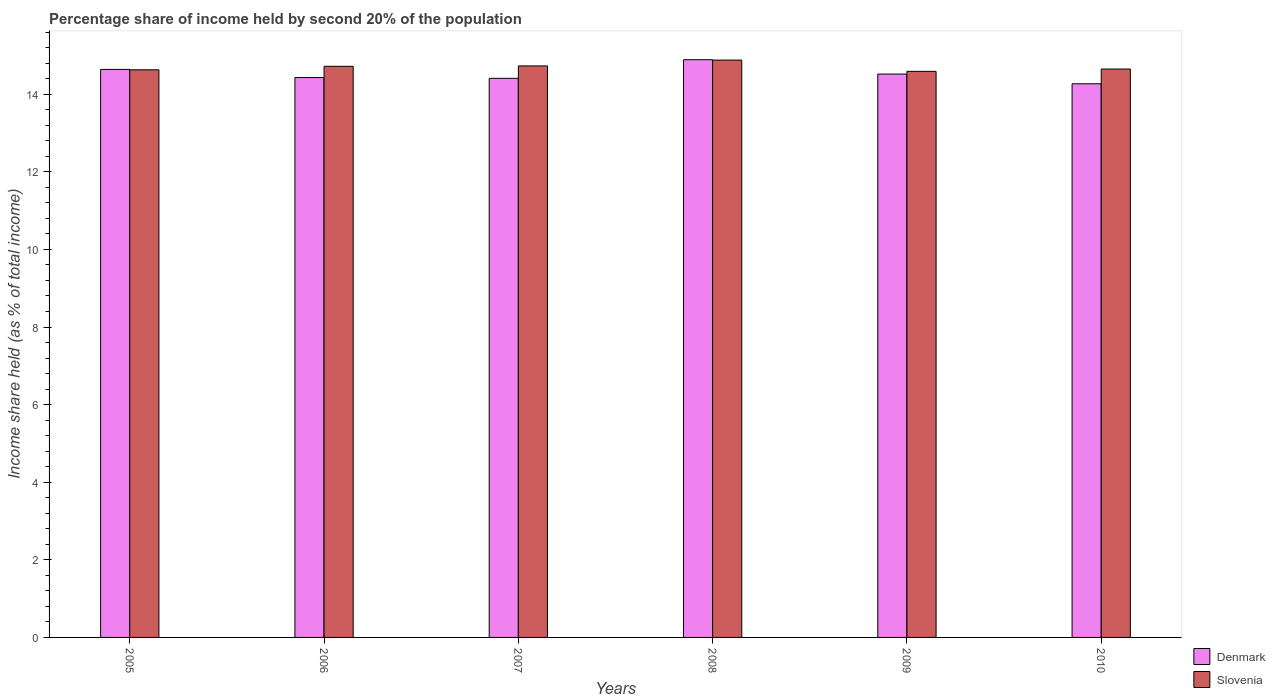How many different coloured bars are there?
Your answer should be compact. 2. How many groups of bars are there?
Provide a succinct answer. 6. How many bars are there on the 1st tick from the left?
Make the answer very short. 2. In how many cases, is the number of bars for a given year not equal to the number of legend labels?
Your response must be concise. 0. What is the share of income held by second 20% of the population in Slovenia in 2008?
Provide a succinct answer. 14.88. Across all years, what is the maximum share of income held by second 20% of the population in Denmark?
Your answer should be compact. 14.89. Across all years, what is the minimum share of income held by second 20% of the population in Slovenia?
Your answer should be compact. 14.59. In which year was the share of income held by second 20% of the population in Slovenia minimum?
Offer a terse response. 2009. What is the total share of income held by second 20% of the population in Slovenia in the graph?
Offer a very short reply. 88.2. What is the difference between the share of income held by second 20% of the population in Denmark in 2006 and that in 2009?
Keep it short and to the point. -0.09. What is the difference between the share of income held by second 20% of the population in Denmark in 2008 and the share of income held by second 20% of the population in Slovenia in 2006?
Make the answer very short. 0.17. What is the average share of income held by second 20% of the population in Denmark per year?
Your answer should be very brief. 14.53. In the year 2005, what is the difference between the share of income held by second 20% of the population in Slovenia and share of income held by second 20% of the population in Denmark?
Make the answer very short. -0.01. In how many years, is the share of income held by second 20% of the population in Slovenia greater than 10.8 %?
Give a very brief answer. 6. What is the ratio of the share of income held by second 20% of the population in Denmark in 2005 to that in 2007?
Your answer should be very brief. 1.02. Is the share of income held by second 20% of the population in Slovenia in 2005 less than that in 2008?
Your answer should be compact. Yes. Is the difference between the share of income held by second 20% of the population in Slovenia in 2006 and 2007 greater than the difference between the share of income held by second 20% of the population in Denmark in 2006 and 2007?
Offer a very short reply. No. What is the difference between the highest and the second highest share of income held by second 20% of the population in Slovenia?
Keep it short and to the point. 0.15. What is the difference between the highest and the lowest share of income held by second 20% of the population in Slovenia?
Your answer should be compact. 0.29. What does the 1st bar from the right in 2005 represents?
Your response must be concise. Slovenia. How many bars are there?
Offer a very short reply. 12. Are all the bars in the graph horizontal?
Give a very brief answer. No. Are the values on the major ticks of Y-axis written in scientific E-notation?
Make the answer very short. No. Does the graph contain any zero values?
Provide a short and direct response. No. Does the graph contain grids?
Give a very brief answer. No. How are the legend labels stacked?
Offer a terse response. Vertical. What is the title of the graph?
Give a very brief answer. Percentage share of income held by second 20% of the population. What is the label or title of the X-axis?
Offer a terse response. Years. What is the label or title of the Y-axis?
Provide a short and direct response. Income share held (as % of total income). What is the Income share held (as % of total income) in Denmark in 2005?
Offer a terse response. 14.64. What is the Income share held (as % of total income) of Slovenia in 2005?
Your answer should be compact. 14.63. What is the Income share held (as % of total income) in Denmark in 2006?
Your response must be concise. 14.43. What is the Income share held (as % of total income) in Slovenia in 2006?
Your answer should be very brief. 14.72. What is the Income share held (as % of total income) in Denmark in 2007?
Your answer should be very brief. 14.41. What is the Income share held (as % of total income) in Slovenia in 2007?
Offer a terse response. 14.73. What is the Income share held (as % of total income) in Denmark in 2008?
Your answer should be very brief. 14.89. What is the Income share held (as % of total income) of Slovenia in 2008?
Make the answer very short. 14.88. What is the Income share held (as % of total income) in Denmark in 2009?
Give a very brief answer. 14.52. What is the Income share held (as % of total income) of Slovenia in 2009?
Your answer should be very brief. 14.59. What is the Income share held (as % of total income) in Denmark in 2010?
Make the answer very short. 14.27. What is the Income share held (as % of total income) in Slovenia in 2010?
Provide a succinct answer. 14.65. Across all years, what is the maximum Income share held (as % of total income) of Denmark?
Keep it short and to the point. 14.89. Across all years, what is the maximum Income share held (as % of total income) of Slovenia?
Make the answer very short. 14.88. Across all years, what is the minimum Income share held (as % of total income) of Denmark?
Offer a very short reply. 14.27. Across all years, what is the minimum Income share held (as % of total income) of Slovenia?
Make the answer very short. 14.59. What is the total Income share held (as % of total income) of Denmark in the graph?
Your response must be concise. 87.16. What is the total Income share held (as % of total income) in Slovenia in the graph?
Your response must be concise. 88.2. What is the difference between the Income share held (as % of total income) in Denmark in 2005 and that in 2006?
Make the answer very short. 0.21. What is the difference between the Income share held (as % of total income) in Slovenia in 2005 and that in 2006?
Offer a very short reply. -0.09. What is the difference between the Income share held (as % of total income) of Denmark in 2005 and that in 2007?
Your response must be concise. 0.23. What is the difference between the Income share held (as % of total income) in Slovenia in 2005 and that in 2007?
Your response must be concise. -0.1. What is the difference between the Income share held (as % of total income) in Slovenia in 2005 and that in 2008?
Offer a very short reply. -0.25. What is the difference between the Income share held (as % of total income) of Denmark in 2005 and that in 2009?
Ensure brevity in your answer.  0.12. What is the difference between the Income share held (as % of total income) of Slovenia in 2005 and that in 2009?
Give a very brief answer. 0.04. What is the difference between the Income share held (as % of total income) in Denmark in 2005 and that in 2010?
Ensure brevity in your answer.  0.37. What is the difference between the Income share held (as % of total income) of Slovenia in 2005 and that in 2010?
Your answer should be compact. -0.02. What is the difference between the Income share held (as % of total income) in Slovenia in 2006 and that in 2007?
Your answer should be compact. -0.01. What is the difference between the Income share held (as % of total income) of Denmark in 2006 and that in 2008?
Ensure brevity in your answer.  -0.46. What is the difference between the Income share held (as % of total income) of Slovenia in 2006 and that in 2008?
Offer a terse response. -0.16. What is the difference between the Income share held (as % of total income) of Denmark in 2006 and that in 2009?
Offer a very short reply. -0.09. What is the difference between the Income share held (as % of total income) of Slovenia in 2006 and that in 2009?
Ensure brevity in your answer.  0.13. What is the difference between the Income share held (as % of total income) in Denmark in 2006 and that in 2010?
Your answer should be compact. 0.16. What is the difference between the Income share held (as % of total income) in Slovenia in 2006 and that in 2010?
Your answer should be very brief. 0.07. What is the difference between the Income share held (as % of total income) of Denmark in 2007 and that in 2008?
Ensure brevity in your answer.  -0.48. What is the difference between the Income share held (as % of total income) of Denmark in 2007 and that in 2009?
Ensure brevity in your answer.  -0.11. What is the difference between the Income share held (as % of total income) of Slovenia in 2007 and that in 2009?
Provide a succinct answer. 0.14. What is the difference between the Income share held (as % of total income) in Denmark in 2007 and that in 2010?
Keep it short and to the point. 0.14. What is the difference between the Income share held (as % of total income) in Slovenia in 2007 and that in 2010?
Provide a succinct answer. 0.08. What is the difference between the Income share held (as % of total income) in Denmark in 2008 and that in 2009?
Give a very brief answer. 0.37. What is the difference between the Income share held (as % of total income) of Slovenia in 2008 and that in 2009?
Offer a very short reply. 0.29. What is the difference between the Income share held (as % of total income) of Denmark in 2008 and that in 2010?
Offer a terse response. 0.62. What is the difference between the Income share held (as % of total income) of Slovenia in 2008 and that in 2010?
Provide a short and direct response. 0.23. What is the difference between the Income share held (as % of total income) of Denmark in 2009 and that in 2010?
Provide a succinct answer. 0.25. What is the difference between the Income share held (as % of total income) of Slovenia in 2009 and that in 2010?
Provide a short and direct response. -0.06. What is the difference between the Income share held (as % of total income) of Denmark in 2005 and the Income share held (as % of total income) of Slovenia in 2006?
Your answer should be very brief. -0.08. What is the difference between the Income share held (as % of total income) in Denmark in 2005 and the Income share held (as % of total income) in Slovenia in 2007?
Your response must be concise. -0.09. What is the difference between the Income share held (as % of total income) in Denmark in 2005 and the Income share held (as % of total income) in Slovenia in 2008?
Your response must be concise. -0.24. What is the difference between the Income share held (as % of total income) in Denmark in 2005 and the Income share held (as % of total income) in Slovenia in 2009?
Give a very brief answer. 0.05. What is the difference between the Income share held (as % of total income) of Denmark in 2005 and the Income share held (as % of total income) of Slovenia in 2010?
Your answer should be very brief. -0.01. What is the difference between the Income share held (as % of total income) of Denmark in 2006 and the Income share held (as % of total income) of Slovenia in 2007?
Your answer should be very brief. -0.3. What is the difference between the Income share held (as % of total income) in Denmark in 2006 and the Income share held (as % of total income) in Slovenia in 2008?
Your answer should be compact. -0.45. What is the difference between the Income share held (as % of total income) in Denmark in 2006 and the Income share held (as % of total income) in Slovenia in 2009?
Your answer should be very brief. -0.16. What is the difference between the Income share held (as % of total income) of Denmark in 2006 and the Income share held (as % of total income) of Slovenia in 2010?
Offer a very short reply. -0.22. What is the difference between the Income share held (as % of total income) of Denmark in 2007 and the Income share held (as % of total income) of Slovenia in 2008?
Provide a short and direct response. -0.47. What is the difference between the Income share held (as % of total income) in Denmark in 2007 and the Income share held (as % of total income) in Slovenia in 2009?
Provide a succinct answer. -0.18. What is the difference between the Income share held (as % of total income) of Denmark in 2007 and the Income share held (as % of total income) of Slovenia in 2010?
Ensure brevity in your answer.  -0.24. What is the difference between the Income share held (as % of total income) in Denmark in 2008 and the Income share held (as % of total income) in Slovenia in 2010?
Give a very brief answer. 0.24. What is the difference between the Income share held (as % of total income) in Denmark in 2009 and the Income share held (as % of total income) in Slovenia in 2010?
Keep it short and to the point. -0.13. What is the average Income share held (as % of total income) in Denmark per year?
Provide a short and direct response. 14.53. What is the average Income share held (as % of total income) in Slovenia per year?
Keep it short and to the point. 14.7. In the year 2005, what is the difference between the Income share held (as % of total income) in Denmark and Income share held (as % of total income) in Slovenia?
Your response must be concise. 0.01. In the year 2006, what is the difference between the Income share held (as % of total income) of Denmark and Income share held (as % of total income) of Slovenia?
Your answer should be very brief. -0.29. In the year 2007, what is the difference between the Income share held (as % of total income) of Denmark and Income share held (as % of total income) of Slovenia?
Your answer should be very brief. -0.32. In the year 2008, what is the difference between the Income share held (as % of total income) in Denmark and Income share held (as % of total income) in Slovenia?
Give a very brief answer. 0.01. In the year 2009, what is the difference between the Income share held (as % of total income) of Denmark and Income share held (as % of total income) of Slovenia?
Give a very brief answer. -0.07. In the year 2010, what is the difference between the Income share held (as % of total income) of Denmark and Income share held (as % of total income) of Slovenia?
Offer a terse response. -0.38. What is the ratio of the Income share held (as % of total income) in Denmark in 2005 to that in 2006?
Your answer should be compact. 1.01. What is the ratio of the Income share held (as % of total income) in Denmark in 2005 to that in 2007?
Provide a short and direct response. 1.02. What is the ratio of the Income share held (as % of total income) of Denmark in 2005 to that in 2008?
Offer a very short reply. 0.98. What is the ratio of the Income share held (as % of total income) in Slovenia in 2005 to that in 2008?
Make the answer very short. 0.98. What is the ratio of the Income share held (as % of total income) of Denmark in 2005 to that in 2009?
Offer a terse response. 1.01. What is the ratio of the Income share held (as % of total income) of Denmark in 2005 to that in 2010?
Ensure brevity in your answer.  1.03. What is the ratio of the Income share held (as % of total income) of Slovenia in 2005 to that in 2010?
Ensure brevity in your answer.  1. What is the ratio of the Income share held (as % of total income) in Slovenia in 2006 to that in 2007?
Provide a short and direct response. 1. What is the ratio of the Income share held (as % of total income) of Denmark in 2006 to that in 2008?
Make the answer very short. 0.97. What is the ratio of the Income share held (as % of total income) of Slovenia in 2006 to that in 2009?
Give a very brief answer. 1.01. What is the ratio of the Income share held (as % of total income) in Denmark in 2006 to that in 2010?
Your answer should be compact. 1.01. What is the ratio of the Income share held (as % of total income) in Slovenia in 2006 to that in 2010?
Your response must be concise. 1. What is the ratio of the Income share held (as % of total income) of Denmark in 2007 to that in 2008?
Ensure brevity in your answer.  0.97. What is the ratio of the Income share held (as % of total income) of Denmark in 2007 to that in 2009?
Keep it short and to the point. 0.99. What is the ratio of the Income share held (as % of total income) in Slovenia in 2007 to that in 2009?
Your answer should be compact. 1.01. What is the ratio of the Income share held (as % of total income) in Denmark in 2007 to that in 2010?
Offer a terse response. 1.01. What is the ratio of the Income share held (as % of total income) in Denmark in 2008 to that in 2009?
Keep it short and to the point. 1.03. What is the ratio of the Income share held (as % of total income) in Slovenia in 2008 to that in 2009?
Give a very brief answer. 1.02. What is the ratio of the Income share held (as % of total income) of Denmark in 2008 to that in 2010?
Offer a very short reply. 1.04. What is the ratio of the Income share held (as % of total income) of Slovenia in 2008 to that in 2010?
Offer a terse response. 1.02. What is the ratio of the Income share held (as % of total income) of Denmark in 2009 to that in 2010?
Offer a terse response. 1.02. What is the difference between the highest and the lowest Income share held (as % of total income) of Denmark?
Ensure brevity in your answer.  0.62. What is the difference between the highest and the lowest Income share held (as % of total income) in Slovenia?
Offer a terse response. 0.29. 